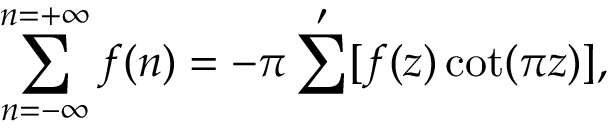Convert formula to latex. <formula><loc_0><loc_0><loc_500><loc_500>\sum _ { n = - \infty } ^ { n = + \infty } f ( n ) = - \pi \sum ^ { \prime } [ f ( z ) \cot ( \pi z ) ] ,</formula> 